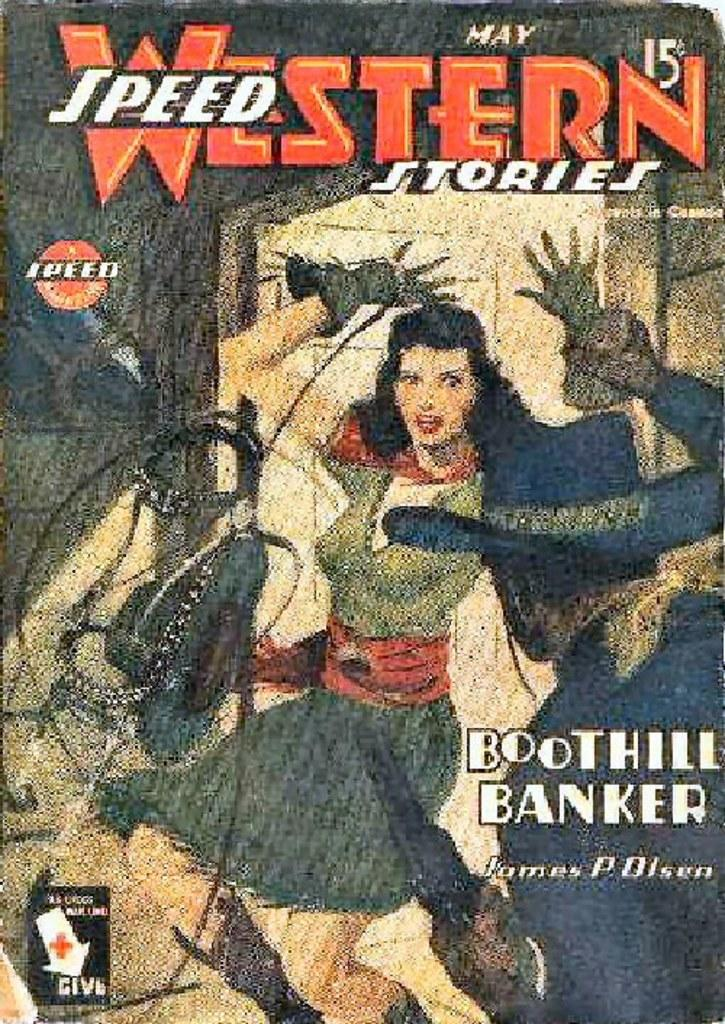<image>
Share a concise interpretation of the image provided. A comic book called Western Speed Stories by James P. Olsen 